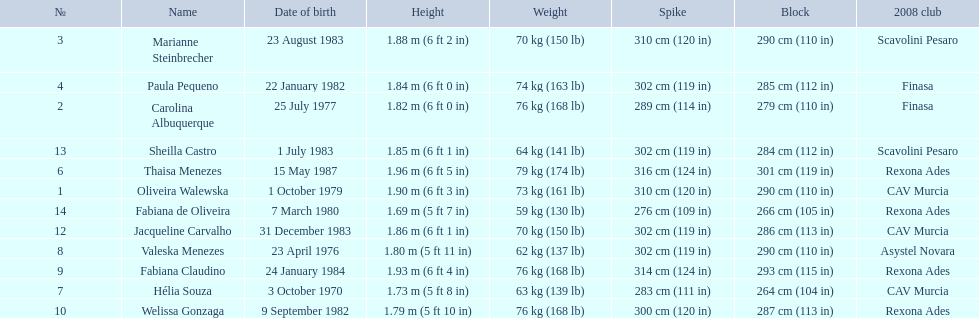Who are the players for brazil at the 2008 summer olympics? Oliveira Walewska, Carolina Albuquerque, Marianne Steinbrecher, Paula Pequeno, Thaisa Menezes, Hélia Souza, Valeska Menezes, Fabiana Claudino, Welissa Gonzaga, Jacqueline Carvalho, Sheilla Castro, Fabiana de Oliveira. What are their heights? 1.90 m (6 ft 3 in), 1.82 m (6 ft 0 in), 1.88 m (6 ft 2 in), 1.84 m (6 ft 0 in), 1.96 m (6 ft 5 in), 1.73 m (5 ft 8 in), 1.80 m (5 ft 11 in), 1.93 m (6 ft 4 in), 1.79 m (5 ft 10 in), 1.86 m (6 ft 1 in), 1.85 m (6 ft 1 in), 1.69 m (5 ft 7 in). What is the shortest height? 1.69 m (5 ft 7 in). Which player is that? Fabiana de Oliveira. 